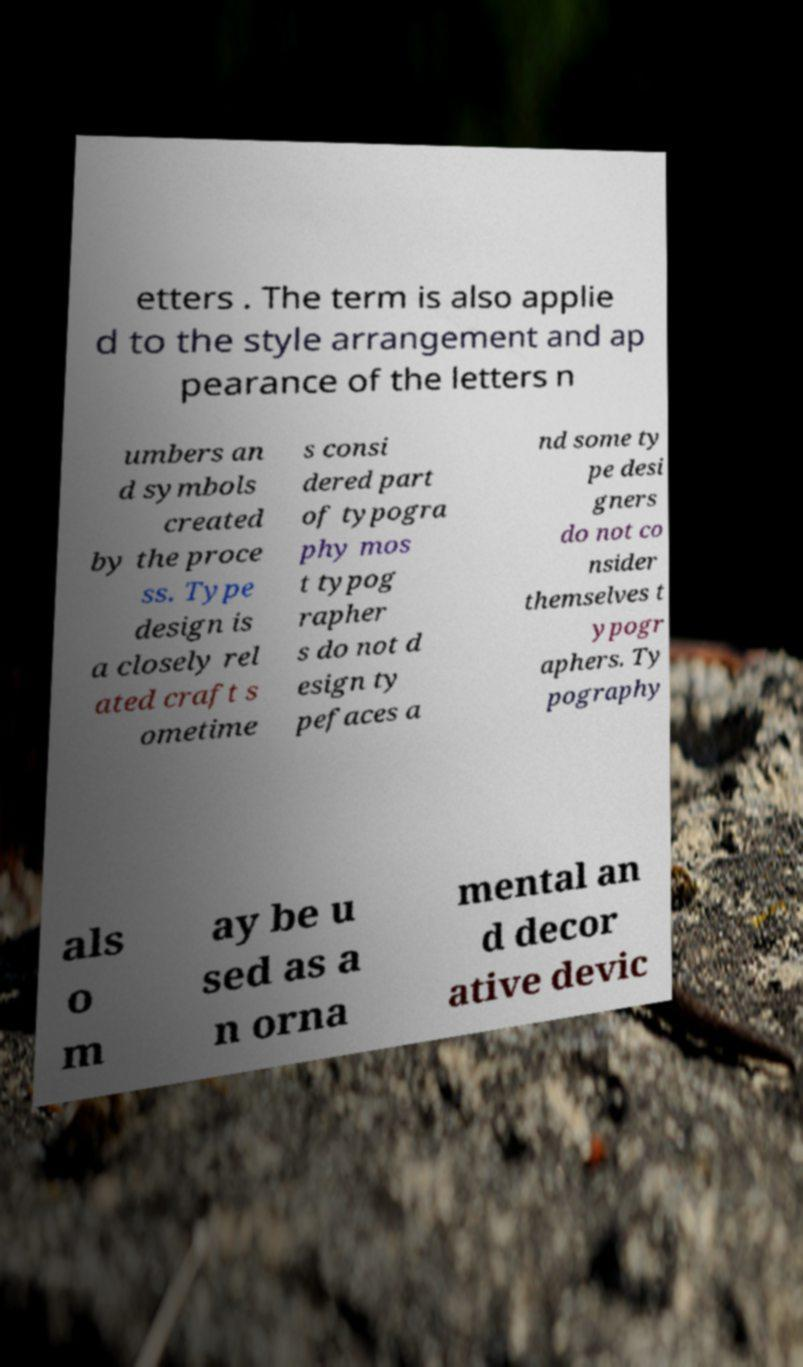For documentation purposes, I need the text within this image transcribed. Could you provide that? etters . The term is also applie d to the style arrangement and ap pearance of the letters n umbers an d symbols created by the proce ss. Type design is a closely rel ated craft s ometime s consi dered part of typogra phy mos t typog rapher s do not d esign ty pefaces a nd some ty pe desi gners do not co nsider themselves t ypogr aphers. Ty pography als o m ay be u sed as a n orna mental an d decor ative devic 